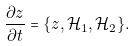Convert formula to latex. <formula><loc_0><loc_0><loc_500><loc_500>\frac { \partial z } { \partial t } = \{ z , \mathcal { H } _ { 1 } , \mathcal { H } _ { 2 } \} .</formula> 